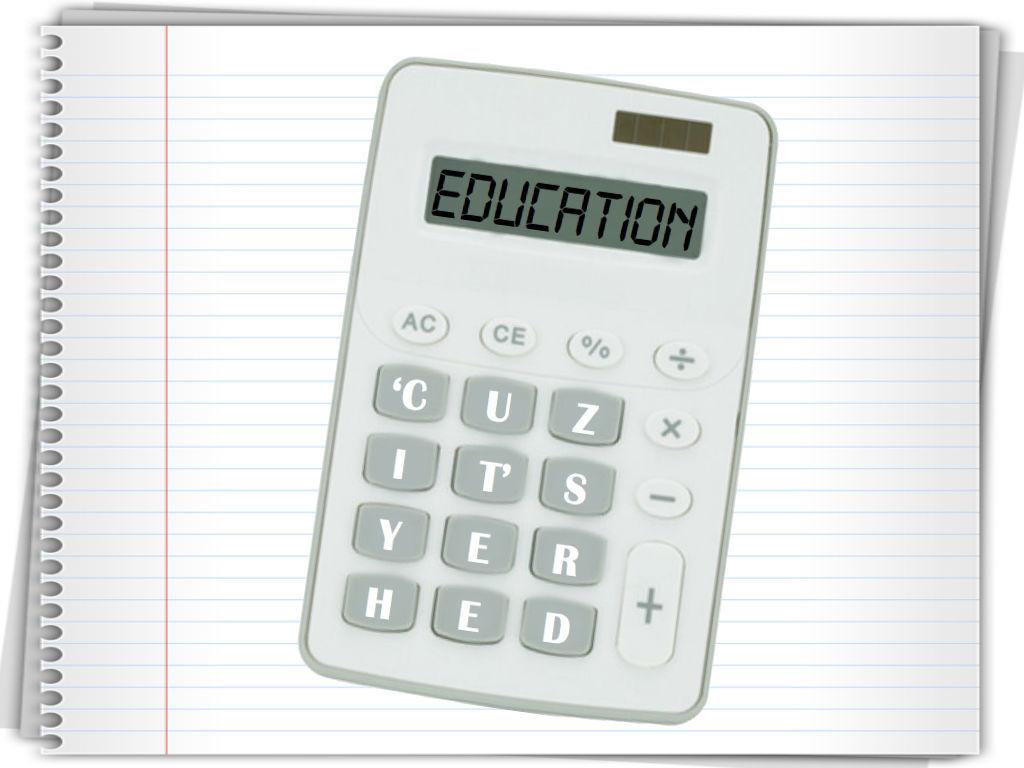What has been spelled out on the display?
Keep it short and to the point. Education. 